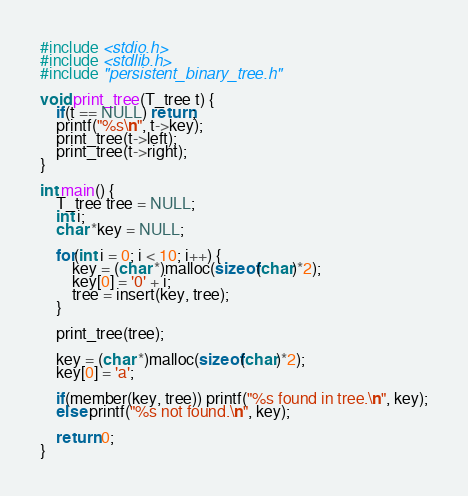<code> <loc_0><loc_0><loc_500><loc_500><_C_>#include <stdio.h>
#include <stdlib.h>
#include "persistent_binary_tree.h"

void print_tree(T_tree t) {
    if(t == NULL) return;
    printf("%s\n", t->key);
    print_tree(t->left);
    print_tree(t->right);
}

int main() {
    T_tree tree = NULL;
    int i;
    char *key = NULL;
    
    for(int i = 0; i < 10; i++) {
        key = (char *)malloc(sizeof(char)*2);
        key[0] = '0' + i;
        tree = insert(key, tree);
    }
    
    print_tree(tree);
    
    key = (char *)malloc(sizeof(char)*2);
    key[0] = 'a';
    
    if(member(key, tree)) printf("%s found in tree.\n", key);
    else printf("%s not found.\n", key);
    
    return 0;
}
</code> 